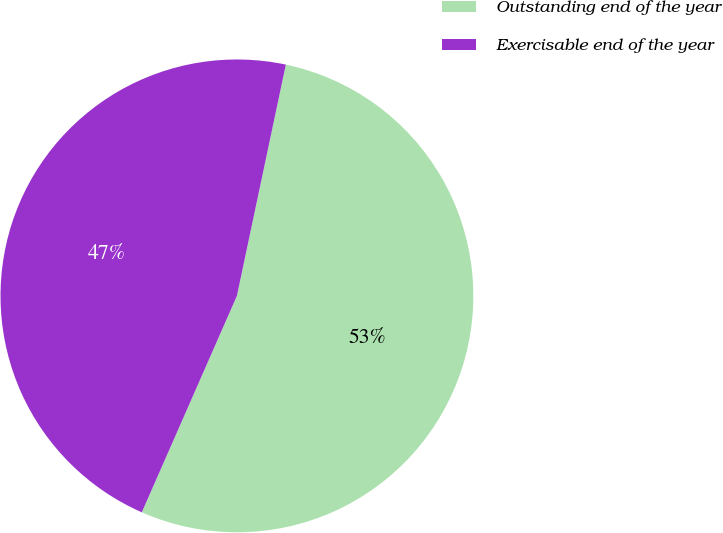Convert chart to OTSL. <chart><loc_0><loc_0><loc_500><loc_500><pie_chart><fcel>Outstanding end of the year<fcel>Exercisable end of the year<nl><fcel>53.27%<fcel>46.73%<nl></chart> 